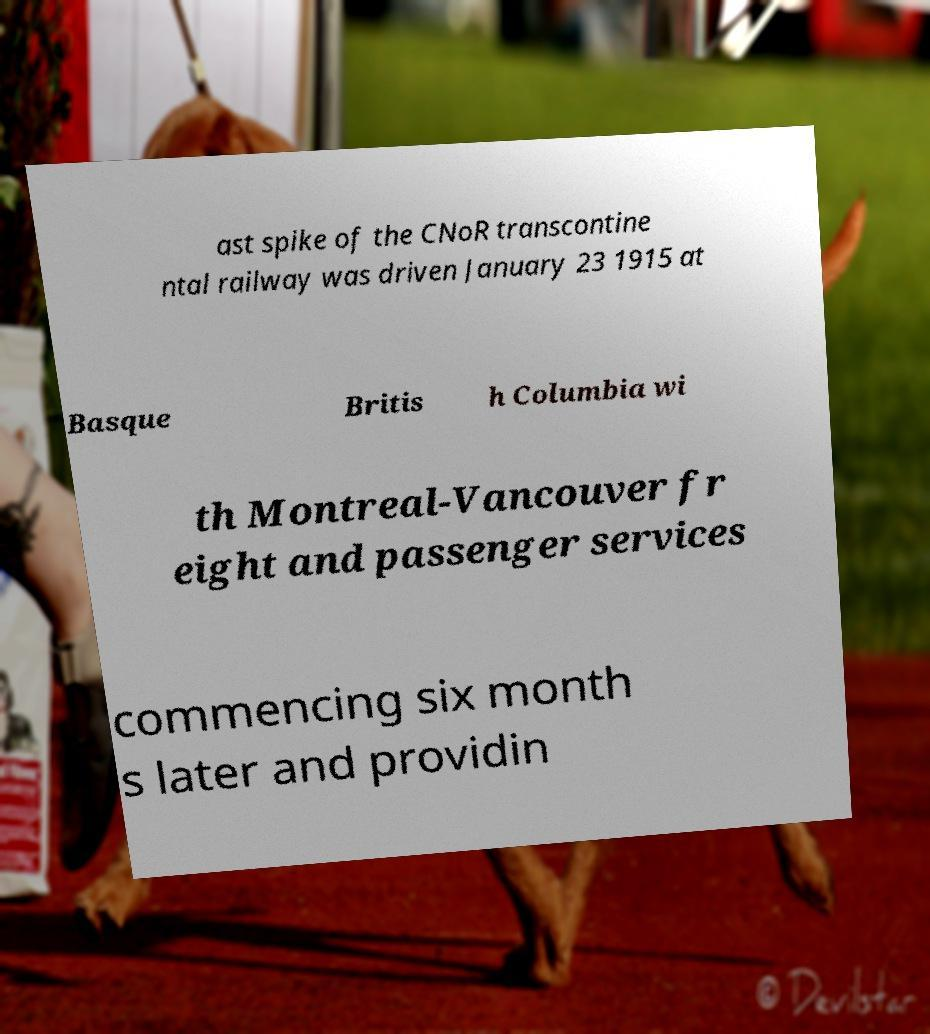Could you extract and type out the text from this image? ast spike of the CNoR transcontine ntal railway was driven January 23 1915 at Basque Britis h Columbia wi th Montreal-Vancouver fr eight and passenger services commencing six month s later and providin 